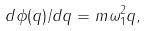<formula> <loc_0><loc_0><loc_500><loc_500>d \phi ( q ) / d q = m \omega _ { 1 } ^ { 2 } q ,</formula> 